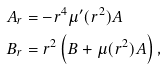Convert formula to latex. <formula><loc_0><loc_0><loc_500><loc_500>A _ { r } & = - r ^ { 4 } { \mu } ^ { \prime } ( r ^ { 2 } ) A \\ B _ { r } & = r ^ { 2 } \left ( B + \mu ( r ^ { 2 } ) A \right ) ,</formula> 